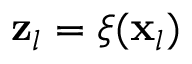Convert formula to latex. <formula><loc_0><loc_0><loc_500><loc_500>z _ { l } = \xi ( x _ { l } )</formula> 